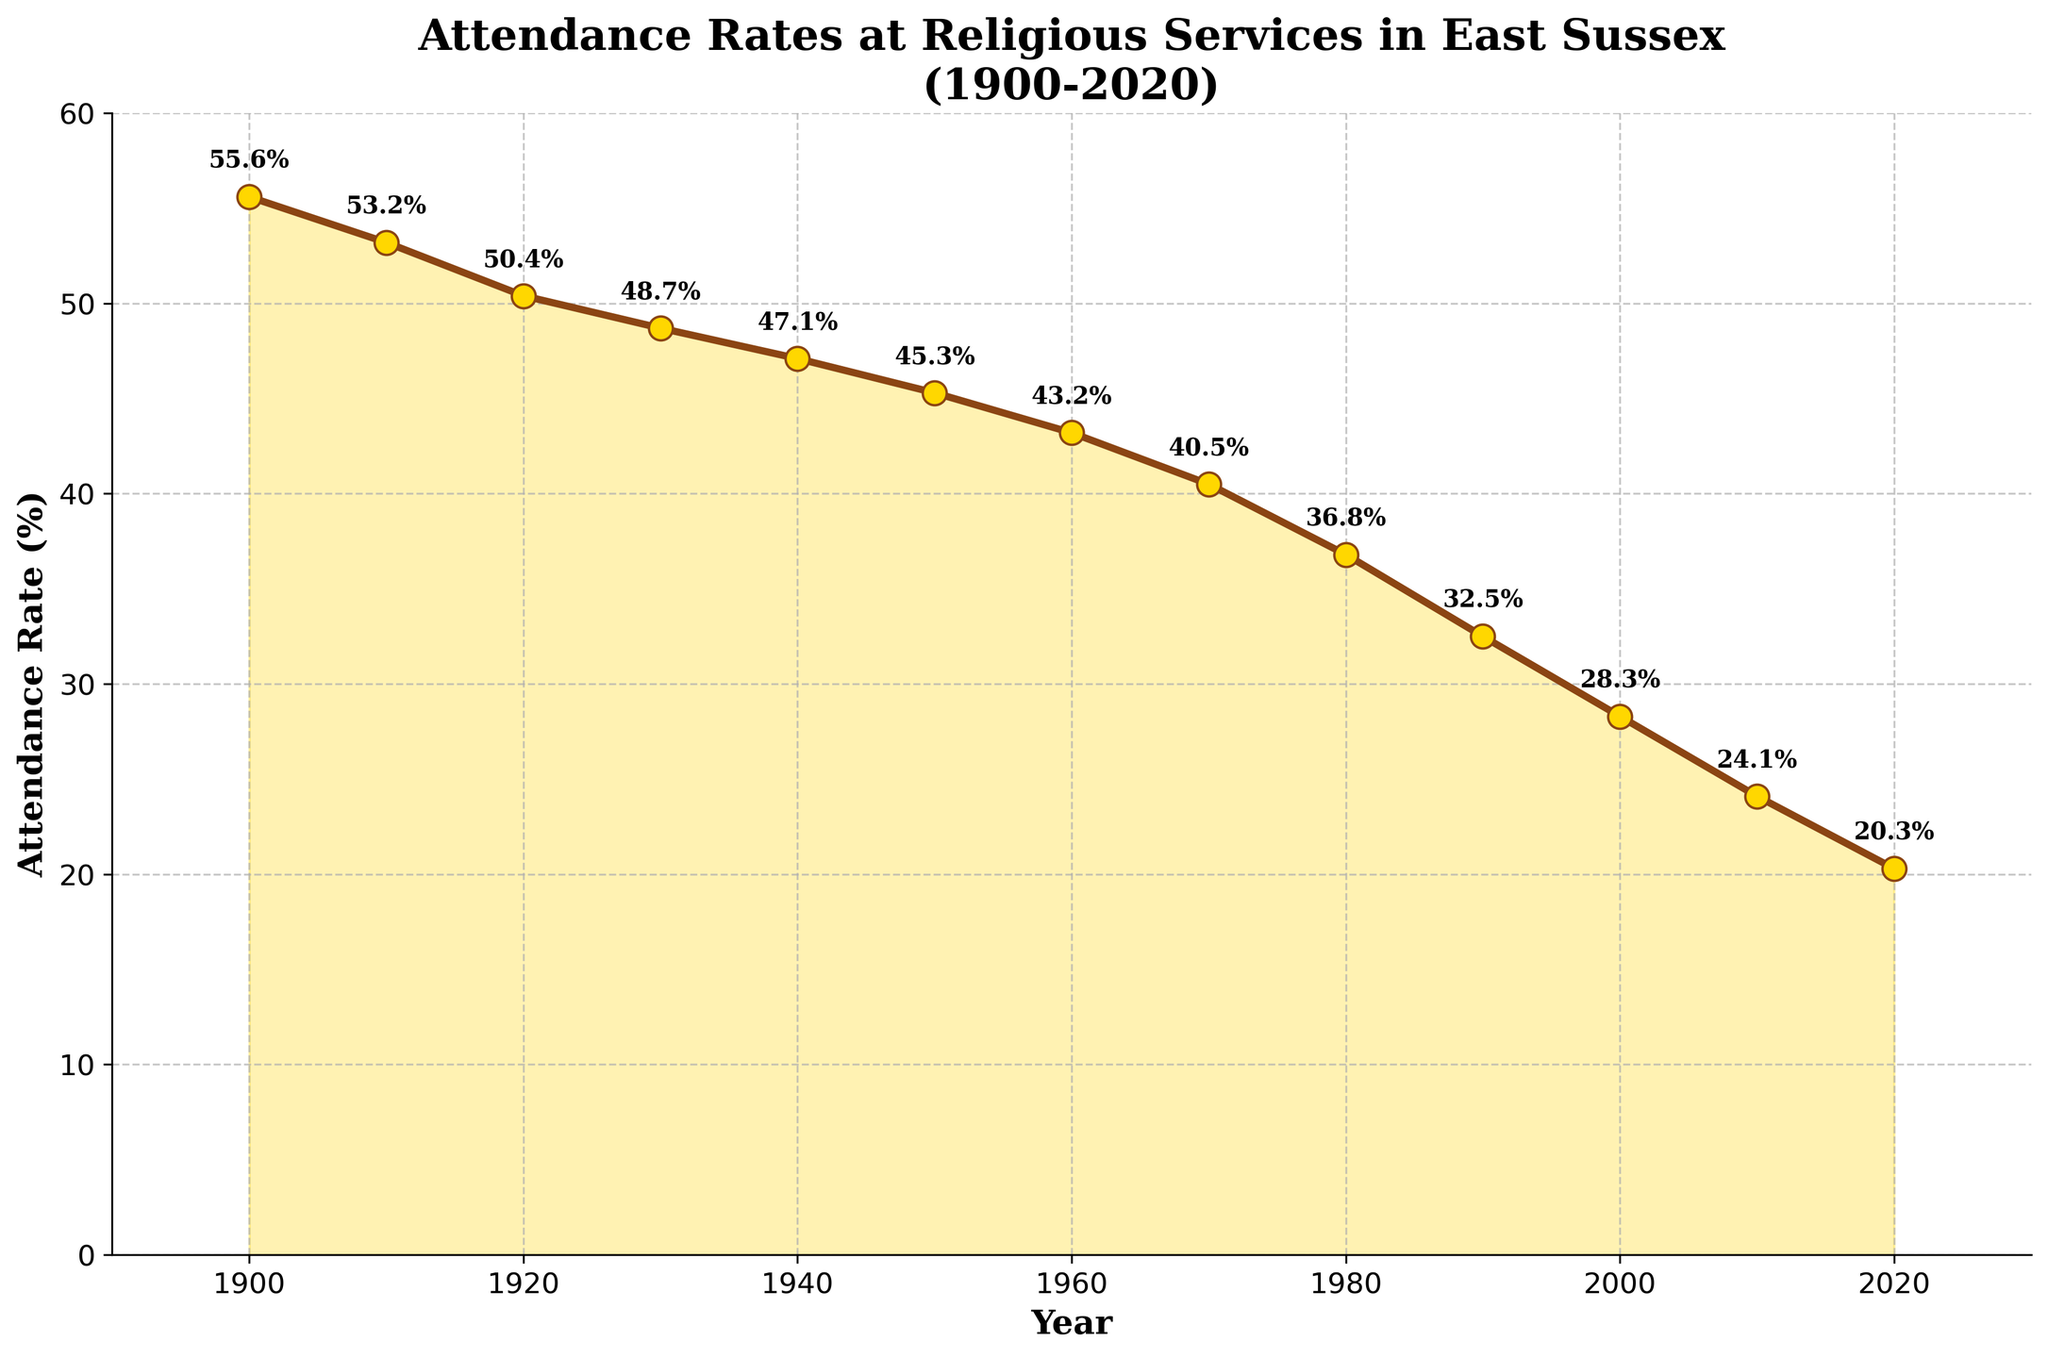What is the title of the plot? The title of the plot is prominently displayed at the top of the figure in bold text.
Answer: Attendance Rates at Religious Services in East Sussex (1900-2020) What are the years at which the attendance rates were recorded? The years are shown as tick marks along the x-axis and also labeled at the x-coordinate of each data point.
Answer: 1900, 1910, 1920, 1930, 1940, 1950, 1960, 1970, 1980, 1990, 2000, 2010, 2020 What is the overall trend observed from 1900 to 2020? By looking at the positions of the data points from left to right, it is clear that the attendance rates have been declining over time.
Answer: Declining What is the attendance rate in 1960? Locate the point labeled '1960' on the x-axis and read the corresponding y-value.
Answer: 43.2% How much did the attendance rate decrease between 1900 and 2020? Subtract the attendance rate in 2020 from the rate in 1900. The rate in 1900 is 55.6% and in 2020 is 20.3%. So, 55.6 - 20.3 = 35.3.
Answer: 35.3% Which decade saw the steepest decline in attendance rates? By comparing the slopes of the line segments between each decade, the steepest decline appears between 1970 and 1980 when the rate fell from 40.5% to 36.8%, a change of 3.7 percentage points.
Answer: 1970-1980 What is the approximate average attendance rate for the entire period from 1900 to 2020? Sum the attendance rates for all years and divide by the number of data points. (55.6+53.2+50.4+48.7+47.1+45.3+43.2+40.5+36.8+32.5+28.3+24.1+20.3)/13 = 39.6.
Answer: 39.6% What is the attendance rate for the mid-point decade (1960)? Check the value at the midpoint of the timeline, which in this case is 1960, directly marked on the x-axis.
Answer: 43.2% Compare the attendance rate of 2000 to that of 1980. Which is higher and by how much? Look at the attendance rates for 2000 (28.3%) and 1980 (36.8%), then subtract 28.3 from 36.8 to find the difference.
Answer: 1980 by 8.5% How does the attendance rate in 1940 compare to that in 2010? Check the respective values for 1940 (47.1%) and 2010 (24.1%), and determine which is higher.
Answer: 1940 is higher 